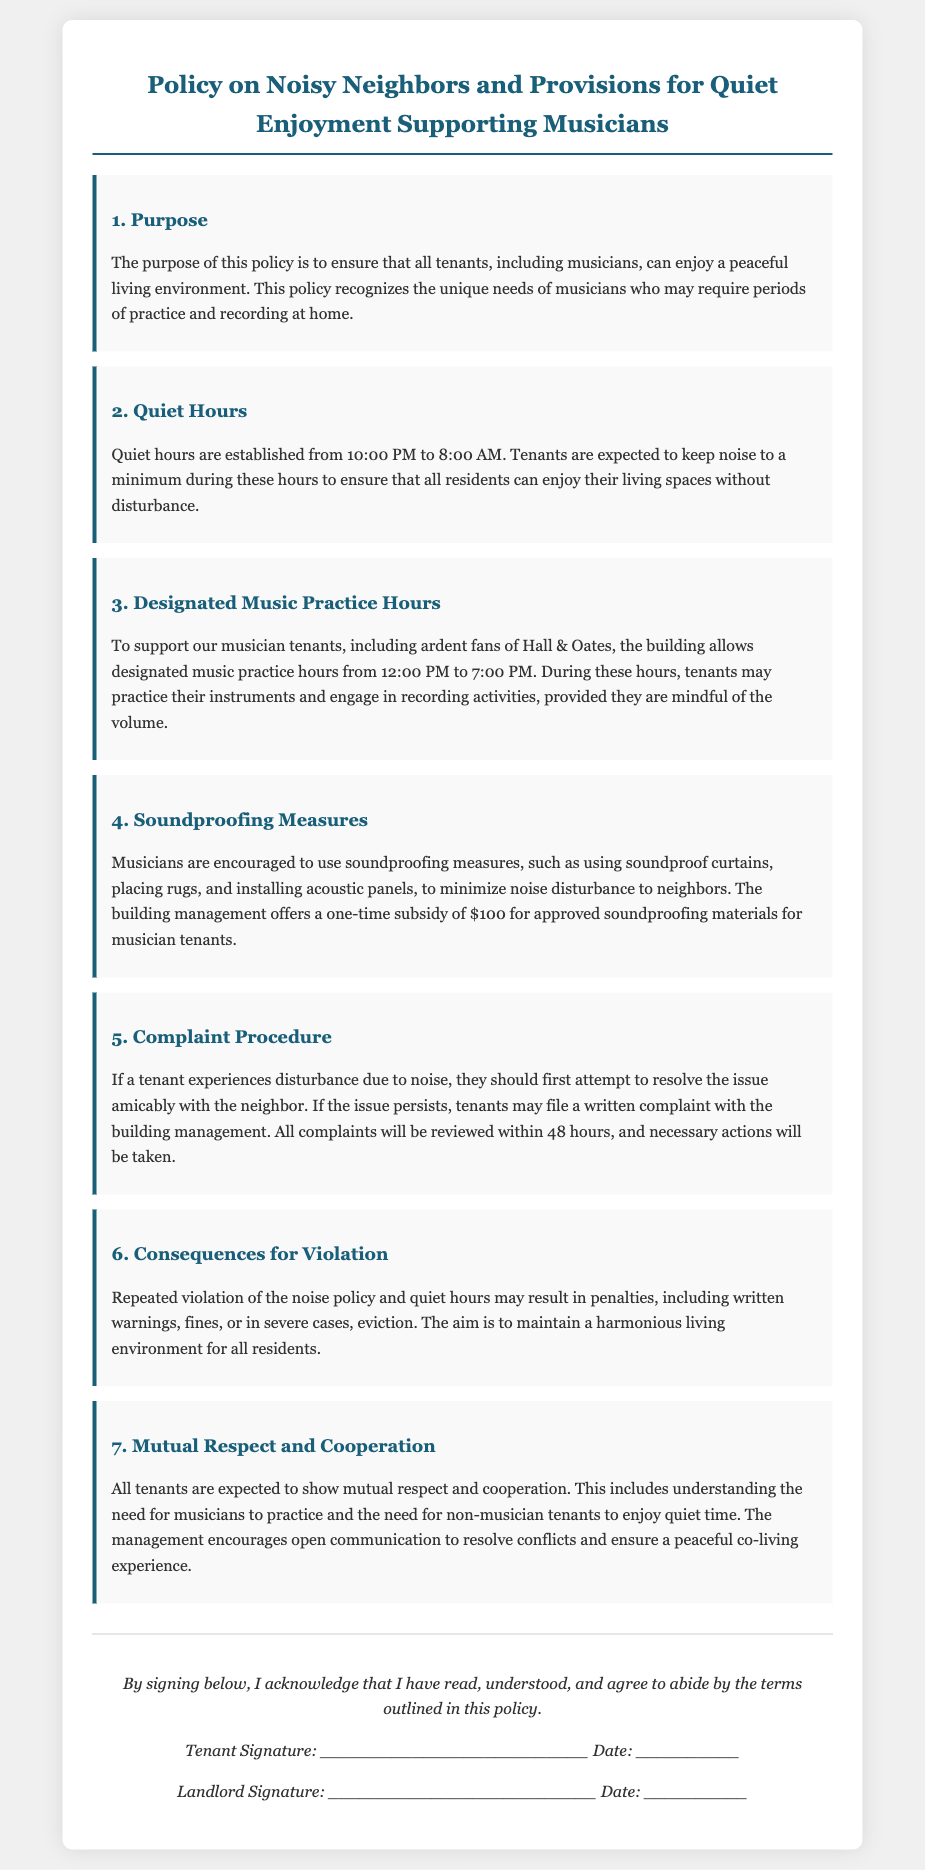what are the established quiet hours? The document specifies that tenants are expected to keep noise to a minimum during the hours of 10:00 PM to 8:00 AM.
Answer: 10:00 PM to 8:00 AM what hours are designated for music practice? The document states that music practice hours are from 12:00 PM to 7:00 PM.
Answer: 12:00 PM to 7:00 PM what subsidy amount is offered for soundproofing materials? According to the document, the building management offers a one-time subsidy of $100 for approved soundproofing materials to musician tenants.
Answer: $100 how quickly will complaints be reviewed? The lease agreement mentions that all complaints will be reviewed within 48 hours.
Answer: 48 hours what is the consequence for repeated violations of the noise policy? The document indicates that repeated violations may result in penalties, which can include written warnings, fines, or even eviction.
Answer: eviction what is the purpose of this policy? The purpose outlined in the document is to ensure that all tenants, including musicians, can enjoy a peaceful living environment.
Answer: peaceful living environment who should tenants first attempt to resolve noise issues with? The document advises that if a tenant experiences noise disturbance, they should first attempt to resolve the issue amicably with the neighbor.
Answer: the neighbor what is expected of all tenants regarding respect and cooperation? The lease specifies that all tenants are expected to show mutual respect and cooperation, including understanding both musicians' needs and non-musicians' needs.
Answer: mutual respect and cooperation 